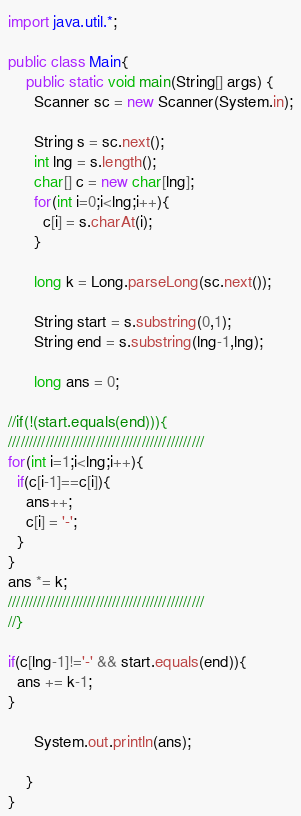<code> <loc_0><loc_0><loc_500><loc_500><_Java_>import java.util.*;

public class Main{
    public static void main(String[] args) {
      Scanner sc = new Scanner(System.in);

      String s = sc.next();
      int lng = s.length();
      char[] c = new char[lng];
      for(int i=0;i<lng;i++){
        c[i] = s.charAt(i);
      }

      long k = Long.parseLong(sc.next());

      String start = s.substring(0,1);
      String end = s.substring(lng-1,lng);

      long ans = 0;

//if(!(start.equals(end))){
///////////////////////////////////////////////
for(int i=1;i<lng;i++){
  if(c[i-1]==c[i]){
    ans++;
    c[i] = '-';
  }
}
ans *= k;
///////////////////////////////////////////////
//}

if(c[lng-1]!='-' && start.equals(end)){
  ans += k-1;
}

      System.out.println(ans);

    }
}
</code> 